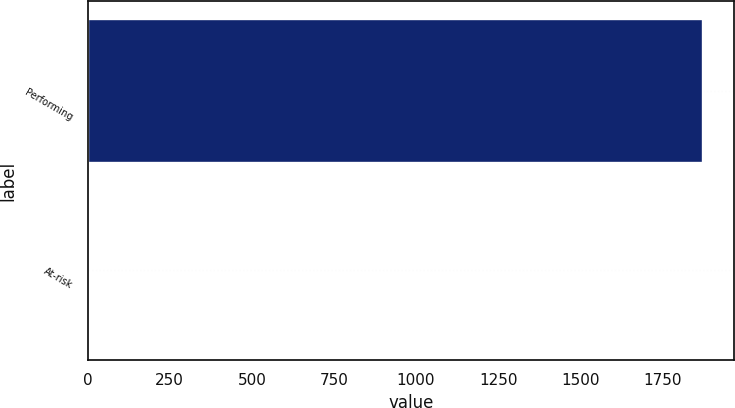Convert chart to OTSL. <chart><loc_0><loc_0><loc_500><loc_500><bar_chart><fcel>Performing<fcel>At-risk<nl><fcel>1874.5<fcel>0.1<nl></chart> 